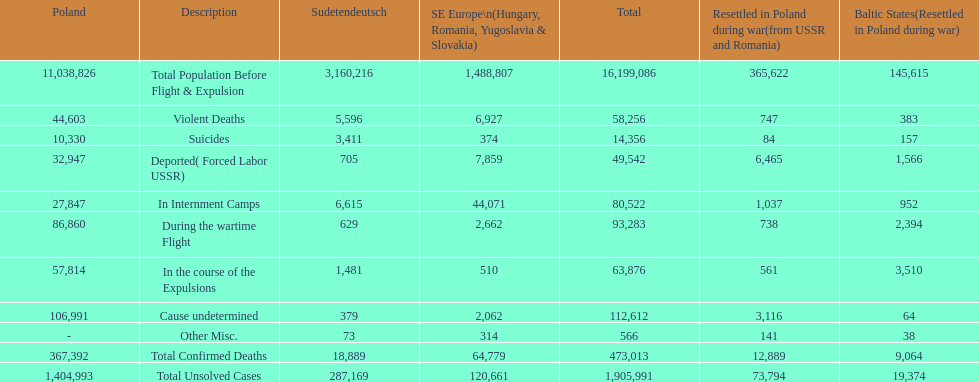What is the total number of violent deaths across all regions? 58,256. 